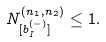Convert formula to latex. <formula><loc_0><loc_0><loc_500><loc_500>N _ { [ b _ { I } ^ { ( - ) } ] } ^ { ( n _ { 1 } , n _ { 2 } ) } \leq 1 .</formula> 